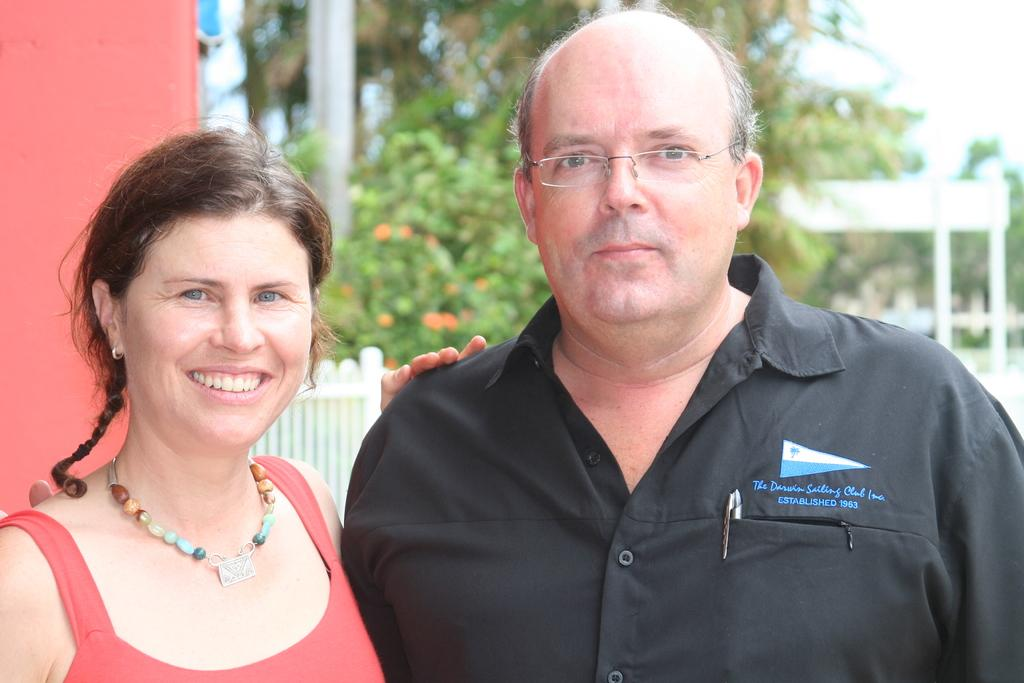How many people are present in the image? There are two persons standing in the image. What can be seen behind the persons? There are many trees at the back side of the persons. What type of plastic material can be seen in the image? There is no plastic material present in the image. How can we help the persons in the image? We cannot help the persons in the image, as it is a static photograph and they do not require assistance. 